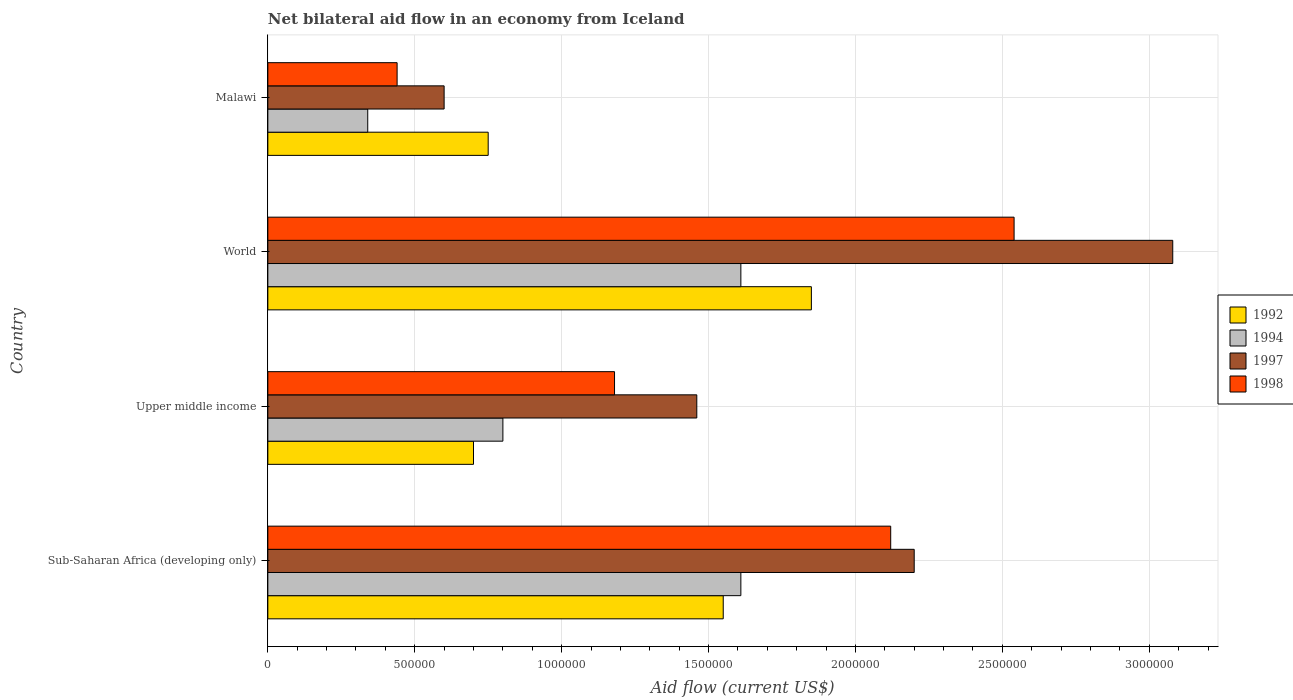How many different coloured bars are there?
Offer a very short reply. 4. Are the number of bars on each tick of the Y-axis equal?
Keep it short and to the point. Yes. How many bars are there on the 1st tick from the bottom?
Provide a succinct answer. 4. What is the label of the 2nd group of bars from the top?
Make the answer very short. World. What is the net bilateral aid flow in 1998 in Upper middle income?
Ensure brevity in your answer.  1.18e+06. Across all countries, what is the maximum net bilateral aid flow in 1998?
Ensure brevity in your answer.  2.54e+06. In which country was the net bilateral aid flow in 1997 maximum?
Provide a succinct answer. World. In which country was the net bilateral aid flow in 1997 minimum?
Provide a short and direct response. Malawi. What is the total net bilateral aid flow in 1992 in the graph?
Make the answer very short. 4.85e+06. What is the difference between the net bilateral aid flow in 1994 in Malawi and that in World?
Your response must be concise. -1.27e+06. What is the difference between the net bilateral aid flow in 1994 in Malawi and the net bilateral aid flow in 1997 in Upper middle income?
Provide a short and direct response. -1.12e+06. What is the average net bilateral aid flow in 1998 per country?
Offer a terse response. 1.57e+06. What is the ratio of the net bilateral aid flow in 1992 in Upper middle income to that in World?
Offer a very short reply. 0.38. What is the difference between the highest and the lowest net bilateral aid flow in 1994?
Your answer should be compact. 1.27e+06. Is it the case that in every country, the sum of the net bilateral aid flow in 1994 and net bilateral aid flow in 1992 is greater than the sum of net bilateral aid flow in 1997 and net bilateral aid flow in 1998?
Make the answer very short. No. What does the 3rd bar from the top in Upper middle income represents?
Offer a terse response. 1994. What does the 2nd bar from the bottom in Malawi represents?
Provide a succinct answer. 1994. Is it the case that in every country, the sum of the net bilateral aid flow in 1992 and net bilateral aid flow in 1994 is greater than the net bilateral aid flow in 1998?
Keep it short and to the point. Yes. Are all the bars in the graph horizontal?
Make the answer very short. Yes. Does the graph contain grids?
Give a very brief answer. Yes. How are the legend labels stacked?
Provide a short and direct response. Vertical. What is the title of the graph?
Provide a succinct answer. Net bilateral aid flow in an economy from Iceland. Does "1975" appear as one of the legend labels in the graph?
Keep it short and to the point. No. What is the Aid flow (current US$) of 1992 in Sub-Saharan Africa (developing only)?
Your answer should be very brief. 1.55e+06. What is the Aid flow (current US$) in 1994 in Sub-Saharan Africa (developing only)?
Give a very brief answer. 1.61e+06. What is the Aid flow (current US$) of 1997 in Sub-Saharan Africa (developing only)?
Keep it short and to the point. 2.20e+06. What is the Aid flow (current US$) of 1998 in Sub-Saharan Africa (developing only)?
Your response must be concise. 2.12e+06. What is the Aid flow (current US$) in 1994 in Upper middle income?
Make the answer very short. 8.00e+05. What is the Aid flow (current US$) in 1997 in Upper middle income?
Your answer should be very brief. 1.46e+06. What is the Aid flow (current US$) of 1998 in Upper middle income?
Your answer should be very brief. 1.18e+06. What is the Aid flow (current US$) in 1992 in World?
Offer a very short reply. 1.85e+06. What is the Aid flow (current US$) of 1994 in World?
Offer a terse response. 1.61e+06. What is the Aid flow (current US$) of 1997 in World?
Provide a short and direct response. 3.08e+06. What is the Aid flow (current US$) of 1998 in World?
Offer a terse response. 2.54e+06. What is the Aid flow (current US$) of 1992 in Malawi?
Your response must be concise. 7.50e+05. What is the Aid flow (current US$) in 1997 in Malawi?
Your response must be concise. 6.00e+05. Across all countries, what is the maximum Aid flow (current US$) of 1992?
Provide a short and direct response. 1.85e+06. Across all countries, what is the maximum Aid flow (current US$) in 1994?
Offer a terse response. 1.61e+06. Across all countries, what is the maximum Aid flow (current US$) of 1997?
Offer a terse response. 3.08e+06. Across all countries, what is the maximum Aid flow (current US$) in 1998?
Give a very brief answer. 2.54e+06. Across all countries, what is the minimum Aid flow (current US$) of 1992?
Offer a terse response. 7.00e+05. Across all countries, what is the minimum Aid flow (current US$) in 1994?
Make the answer very short. 3.40e+05. Across all countries, what is the minimum Aid flow (current US$) of 1998?
Offer a very short reply. 4.40e+05. What is the total Aid flow (current US$) in 1992 in the graph?
Provide a short and direct response. 4.85e+06. What is the total Aid flow (current US$) in 1994 in the graph?
Your response must be concise. 4.36e+06. What is the total Aid flow (current US$) in 1997 in the graph?
Your answer should be very brief. 7.34e+06. What is the total Aid flow (current US$) of 1998 in the graph?
Provide a succinct answer. 6.28e+06. What is the difference between the Aid flow (current US$) of 1992 in Sub-Saharan Africa (developing only) and that in Upper middle income?
Provide a succinct answer. 8.50e+05. What is the difference between the Aid flow (current US$) in 1994 in Sub-Saharan Africa (developing only) and that in Upper middle income?
Ensure brevity in your answer.  8.10e+05. What is the difference between the Aid flow (current US$) in 1997 in Sub-Saharan Africa (developing only) and that in Upper middle income?
Make the answer very short. 7.40e+05. What is the difference between the Aid flow (current US$) of 1998 in Sub-Saharan Africa (developing only) and that in Upper middle income?
Your answer should be very brief. 9.40e+05. What is the difference between the Aid flow (current US$) in 1997 in Sub-Saharan Africa (developing only) and that in World?
Provide a succinct answer. -8.80e+05. What is the difference between the Aid flow (current US$) of 1998 in Sub-Saharan Africa (developing only) and that in World?
Your answer should be very brief. -4.20e+05. What is the difference between the Aid flow (current US$) in 1994 in Sub-Saharan Africa (developing only) and that in Malawi?
Make the answer very short. 1.27e+06. What is the difference between the Aid flow (current US$) in 1997 in Sub-Saharan Africa (developing only) and that in Malawi?
Keep it short and to the point. 1.60e+06. What is the difference between the Aid flow (current US$) in 1998 in Sub-Saharan Africa (developing only) and that in Malawi?
Keep it short and to the point. 1.68e+06. What is the difference between the Aid flow (current US$) of 1992 in Upper middle income and that in World?
Give a very brief answer. -1.15e+06. What is the difference between the Aid flow (current US$) in 1994 in Upper middle income and that in World?
Your response must be concise. -8.10e+05. What is the difference between the Aid flow (current US$) of 1997 in Upper middle income and that in World?
Offer a very short reply. -1.62e+06. What is the difference between the Aid flow (current US$) in 1998 in Upper middle income and that in World?
Offer a terse response. -1.36e+06. What is the difference between the Aid flow (current US$) of 1997 in Upper middle income and that in Malawi?
Keep it short and to the point. 8.60e+05. What is the difference between the Aid flow (current US$) in 1998 in Upper middle income and that in Malawi?
Ensure brevity in your answer.  7.40e+05. What is the difference between the Aid flow (current US$) of 1992 in World and that in Malawi?
Make the answer very short. 1.10e+06. What is the difference between the Aid flow (current US$) in 1994 in World and that in Malawi?
Give a very brief answer. 1.27e+06. What is the difference between the Aid flow (current US$) of 1997 in World and that in Malawi?
Make the answer very short. 2.48e+06. What is the difference between the Aid flow (current US$) in 1998 in World and that in Malawi?
Offer a very short reply. 2.10e+06. What is the difference between the Aid flow (current US$) in 1992 in Sub-Saharan Africa (developing only) and the Aid flow (current US$) in 1994 in Upper middle income?
Your answer should be very brief. 7.50e+05. What is the difference between the Aid flow (current US$) of 1994 in Sub-Saharan Africa (developing only) and the Aid flow (current US$) of 1998 in Upper middle income?
Your response must be concise. 4.30e+05. What is the difference between the Aid flow (current US$) of 1997 in Sub-Saharan Africa (developing only) and the Aid flow (current US$) of 1998 in Upper middle income?
Provide a succinct answer. 1.02e+06. What is the difference between the Aid flow (current US$) of 1992 in Sub-Saharan Africa (developing only) and the Aid flow (current US$) of 1997 in World?
Make the answer very short. -1.53e+06. What is the difference between the Aid flow (current US$) in 1992 in Sub-Saharan Africa (developing only) and the Aid flow (current US$) in 1998 in World?
Offer a very short reply. -9.90e+05. What is the difference between the Aid flow (current US$) of 1994 in Sub-Saharan Africa (developing only) and the Aid flow (current US$) of 1997 in World?
Keep it short and to the point. -1.47e+06. What is the difference between the Aid flow (current US$) in 1994 in Sub-Saharan Africa (developing only) and the Aid flow (current US$) in 1998 in World?
Offer a very short reply. -9.30e+05. What is the difference between the Aid flow (current US$) of 1997 in Sub-Saharan Africa (developing only) and the Aid flow (current US$) of 1998 in World?
Ensure brevity in your answer.  -3.40e+05. What is the difference between the Aid flow (current US$) in 1992 in Sub-Saharan Africa (developing only) and the Aid flow (current US$) in 1994 in Malawi?
Give a very brief answer. 1.21e+06. What is the difference between the Aid flow (current US$) in 1992 in Sub-Saharan Africa (developing only) and the Aid flow (current US$) in 1997 in Malawi?
Make the answer very short. 9.50e+05. What is the difference between the Aid flow (current US$) in 1992 in Sub-Saharan Africa (developing only) and the Aid flow (current US$) in 1998 in Malawi?
Make the answer very short. 1.11e+06. What is the difference between the Aid flow (current US$) in 1994 in Sub-Saharan Africa (developing only) and the Aid flow (current US$) in 1997 in Malawi?
Your answer should be compact. 1.01e+06. What is the difference between the Aid flow (current US$) of 1994 in Sub-Saharan Africa (developing only) and the Aid flow (current US$) of 1998 in Malawi?
Your response must be concise. 1.17e+06. What is the difference between the Aid flow (current US$) of 1997 in Sub-Saharan Africa (developing only) and the Aid flow (current US$) of 1998 in Malawi?
Provide a short and direct response. 1.76e+06. What is the difference between the Aid flow (current US$) in 1992 in Upper middle income and the Aid flow (current US$) in 1994 in World?
Offer a very short reply. -9.10e+05. What is the difference between the Aid flow (current US$) in 1992 in Upper middle income and the Aid flow (current US$) in 1997 in World?
Provide a succinct answer. -2.38e+06. What is the difference between the Aid flow (current US$) of 1992 in Upper middle income and the Aid flow (current US$) of 1998 in World?
Keep it short and to the point. -1.84e+06. What is the difference between the Aid flow (current US$) in 1994 in Upper middle income and the Aid flow (current US$) in 1997 in World?
Provide a succinct answer. -2.28e+06. What is the difference between the Aid flow (current US$) in 1994 in Upper middle income and the Aid flow (current US$) in 1998 in World?
Give a very brief answer. -1.74e+06. What is the difference between the Aid flow (current US$) of 1997 in Upper middle income and the Aid flow (current US$) of 1998 in World?
Ensure brevity in your answer.  -1.08e+06. What is the difference between the Aid flow (current US$) of 1992 in Upper middle income and the Aid flow (current US$) of 1994 in Malawi?
Keep it short and to the point. 3.60e+05. What is the difference between the Aid flow (current US$) of 1992 in Upper middle income and the Aid flow (current US$) of 1998 in Malawi?
Offer a terse response. 2.60e+05. What is the difference between the Aid flow (current US$) in 1994 in Upper middle income and the Aid flow (current US$) in 1997 in Malawi?
Offer a very short reply. 2.00e+05. What is the difference between the Aid flow (current US$) in 1994 in Upper middle income and the Aid flow (current US$) in 1998 in Malawi?
Make the answer very short. 3.60e+05. What is the difference between the Aid flow (current US$) in 1997 in Upper middle income and the Aid flow (current US$) in 1998 in Malawi?
Provide a short and direct response. 1.02e+06. What is the difference between the Aid flow (current US$) in 1992 in World and the Aid flow (current US$) in 1994 in Malawi?
Make the answer very short. 1.51e+06. What is the difference between the Aid flow (current US$) in 1992 in World and the Aid flow (current US$) in 1997 in Malawi?
Provide a short and direct response. 1.25e+06. What is the difference between the Aid flow (current US$) of 1992 in World and the Aid flow (current US$) of 1998 in Malawi?
Provide a succinct answer. 1.41e+06. What is the difference between the Aid flow (current US$) in 1994 in World and the Aid flow (current US$) in 1997 in Malawi?
Your answer should be very brief. 1.01e+06. What is the difference between the Aid flow (current US$) of 1994 in World and the Aid flow (current US$) of 1998 in Malawi?
Keep it short and to the point. 1.17e+06. What is the difference between the Aid flow (current US$) in 1997 in World and the Aid flow (current US$) in 1998 in Malawi?
Give a very brief answer. 2.64e+06. What is the average Aid flow (current US$) in 1992 per country?
Give a very brief answer. 1.21e+06. What is the average Aid flow (current US$) in 1994 per country?
Make the answer very short. 1.09e+06. What is the average Aid flow (current US$) of 1997 per country?
Your answer should be very brief. 1.84e+06. What is the average Aid flow (current US$) in 1998 per country?
Give a very brief answer. 1.57e+06. What is the difference between the Aid flow (current US$) in 1992 and Aid flow (current US$) in 1994 in Sub-Saharan Africa (developing only)?
Ensure brevity in your answer.  -6.00e+04. What is the difference between the Aid flow (current US$) of 1992 and Aid flow (current US$) of 1997 in Sub-Saharan Africa (developing only)?
Your answer should be very brief. -6.50e+05. What is the difference between the Aid flow (current US$) of 1992 and Aid flow (current US$) of 1998 in Sub-Saharan Africa (developing only)?
Offer a terse response. -5.70e+05. What is the difference between the Aid flow (current US$) in 1994 and Aid flow (current US$) in 1997 in Sub-Saharan Africa (developing only)?
Make the answer very short. -5.90e+05. What is the difference between the Aid flow (current US$) in 1994 and Aid flow (current US$) in 1998 in Sub-Saharan Africa (developing only)?
Ensure brevity in your answer.  -5.10e+05. What is the difference between the Aid flow (current US$) in 1992 and Aid flow (current US$) in 1997 in Upper middle income?
Offer a terse response. -7.60e+05. What is the difference between the Aid flow (current US$) in 1992 and Aid flow (current US$) in 1998 in Upper middle income?
Your response must be concise. -4.80e+05. What is the difference between the Aid flow (current US$) of 1994 and Aid flow (current US$) of 1997 in Upper middle income?
Make the answer very short. -6.60e+05. What is the difference between the Aid flow (current US$) of 1994 and Aid flow (current US$) of 1998 in Upper middle income?
Give a very brief answer. -3.80e+05. What is the difference between the Aid flow (current US$) in 1997 and Aid flow (current US$) in 1998 in Upper middle income?
Your answer should be compact. 2.80e+05. What is the difference between the Aid flow (current US$) of 1992 and Aid flow (current US$) of 1994 in World?
Give a very brief answer. 2.40e+05. What is the difference between the Aid flow (current US$) in 1992 and Aid flow (current US$) in 1997 in World?
Offer a terse response. -1.23e+06. What is the difference between the Aid flow (current US$) in 1992 and Aid flow (current US$) in 1998 in World?
Offer a terse response. -6.90e+05. What is the difference between the Aid flow (current US$) of 1994 and Aid flow (current US$) of 1997 in World?
Offer a very short reply. -1.47e+06. What is the difference between the Aid flow (current US$) of 1994 and Aid flow (current US$) of 1998 in World?
Make the answer very short. -9.30e+05. What is the difference between the Aid flow (current US$) of 1997 and Aid flow (current US$) of 1998 in World?
Provide a short and direct response. 5.40e+05. What is the difference between the Aid flow (current US$) of 1992 and Aid flow (current US$) of 1994 in Malawi?
Offer a very short reply. 4.10e+05. What is the difference between the Aid flow (current US$) in 1994 and Aid flow (current US$) in 1997 in Malawi?
Provide a short and direct response. -2.60e+05. What is the difference between the Aid flow (current US$) in 1994 and Aid flow (current US$) in 1998 in Malawi?
Your response must be concise. -1.00e+05. What is the ratio of the Aid flow (current US$) in 1992 in Sub-Saharan Africa (developing only) to that in Upper middle income?
Provide a short and direct response. 2.21. What is the ratio of the Aid flow (current US$) of 1994 in Sub-Saharan Africa (developing only) to that in Upper middle income?
Offer a terse response. 2.01. What is the ratio of the Aid flow (current US$) of 1997 in Sub-Saharan Africa (developing only) to that in Upper middle income?
Ensure brevity in your answer.  1.51. What is the ratio of the Aid flow (current US$) in 1998 in Sub-Saharan Africa (developing only) to that in Upper middle income?
Provide a succinct answer. 1.8. What is the ratio of the Aid flow (current US$) of 1992 in Sub-Saharan Africa (developing only) to that in World?
Provide a succinct answer. 0.84. What is the ratio of the Aid flow (current US$) of 1997 in Sub-Saharan Africa (developing only) to that in World?
Provide a short and direct response. 0.71. What is the ratio of the Aid flow (current US$) in 1998 in Sub-Saharan Africa (developing only) to that in World?
Give a very brief answer. 0.83. What is the ratio of the Aid flow (current US$) in 1992 in Sub-Saharan Africa (developing only) to that in Malawi?
Keep it short and to the point. 2.07. What is the ratio of the Aid flow (current US$) of 1994 in Sub-Saharan Africa (developing only) to that in Malawi?
Offer a terse response. 4.74. What is the ratio of the Aid flow (current US$) in 1997 in Sub-Saharan Africa (developing only) to that in Malawi?
Provide a short and direct response. 3.67. What is the ratio of the Aid flow (current US$) in 1998 in Sub-Saharan Africa (developing only) to that in Malawi?
Your response must be concise. 4.82. What is the ratio of the Aid flow (current US$) of 1992 in Upper middle income to that in World?
Ensure brevity in your answer.  0.38. What is the ratio of the Aid flow (current US$) of 1994 in Upper middle income to that in World?
Offer a terse response. 0.5. What is the ratio of the Aid flow (current US$) in 1997 in Upper middle income to that in World?
Your response must be concise. 0.47. What is the ratio of the Aid flow (current US$) of 1998 in Upper middle income to that in World?
Your response must be concise. 0.46. What is the ratio of the Aid flow (current US$) of 1992 in Upper middle income to that in Malawi?
Ensure brevity in your answer.  0.93. What is the ratio of the Aid flow (current US$) of 1994 in Upper middle income to that in Malawi?
Offer a terse response. 2.35. What is the ratio of the Aid flow (current US$) in 1997 in Upper middle income to that in Malawi?
Your response must be concise. 2.43. What is the ratio of the Aid flow (current US$) of 1998 in Upper middle income to that in Malawi?
Provide a succinct answer. 2.68. What is the ratio of the Aid flow (current US$) in 1992 in World to that in Malawi?
Provide a succinct answer. 2.47. What is the ratio of the Aid flow (current US$) of 1994 in World to that in Malawi?
Provide a succinct answer. 4.74. What is the ratio of the Aid flow (current US$) of 1997 in World to that in Malawi?
Your answer should be very brief. 5.13. What is the ratio of the Aid flow (current US$) of 1998 in World to that in Malawi?
Provide a succinct answer. 5.77. What is the difference between the highest and the second highest Aid flow (current US$) of 1997?
Provide a short and direct response. 8.80e+05. What is the difference between the highest and the second highest Aid flow (current US$) in 1998?
Keep it short and to the point. 4.20e+05. What is the difference between the highest and the lowest Aid flow (current US$) in 1992?
Your answer should be very brief. 1.15e+06. What is the difference between the highest and the lowest Aid flow (current US$) of 1994?
Make the answer very short. 1.27e+06. What is the difference between the highest and the lowest Aid flow (current US$) in 1997?
Your answer should be very brief. 2.48e+06. What is the difference between the highest and the lowest Aid flow (current US$) in 1998?
Your answer should be compact. 2.10e+06. 